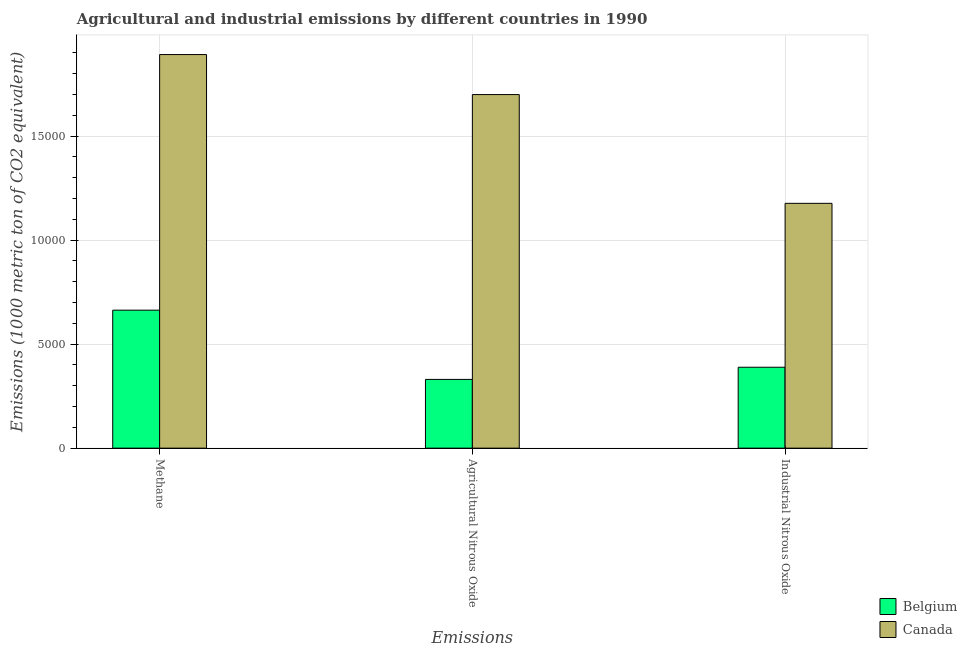How many groups of bars are there?
Make the answer very short. 3. Are the number of bars on each tick of the X-axis equal?
Offer a terse response. Yes. How many bars are there on the 1st tick from the left?
Make the answer very short. 2. What is the label of the 2nd group of bars from the left?
Your response must be concise. Agricultural Nitrous Oxide. What is the amount of agricultural nitrous oxide emissions in Canada?
Make the answer very short. 1.70e+04. Across all countries, what is the maximum amount of industrial nitrous oxide emissions?
Provide a succinct answer. 1.18e+04. Across all countries, what is the minimum amount of agricultural nitrous oxide emissions?
Your answer should be very brief. 3305.4. In which country was the amount of industrial nitrous oxide emissions maximum?
Offer a terse response. Canada. What is the total amount of agricultural nitrous oxide emissions in the graph?
Make the answer very short. 2.03e+04. What is the difference between the amount of industrial nitrous oxide emissions in Canada and that in Belgium?
Give a very brief answer. 7880.4. What is the difference between the amount of methane emissions in Belgium and the amount of industrial nitrous oxide emissions in Canada?
Ensure brevity in your answer.  -5135.7. What is the average amount of agricultural nitrous oxide emissions per country?
Your answer should be compact. 1.02e+04. What is the difference between the amount of methane emissions and amount of agricultural nitrous oxide emissions in Belgium?
Your response must be concise. 3328.9. What is the ratio of the amount of industrial nitrous oxide emissions in Belgium to that in Canada?
Your answer should be compact. 0.33. What is the difference between the highest and the second highest amount of industrial nitrous oxide emissions?
Keep it short and to the point. 7880.4. What is the difference between the highest and the lowest amount of industrial nitrous oxide emissions?
Keep it short and to the point. 7880.4. In how many countries, is the amount of industrial nitrous oxide emissions greater than the average amount of industrial nitrous oxide emissions taken over all countries?
Your answer should be very brief. 1. How many bars are there?
Your answer should be very brief. 6. Are all the bars in the graph horizontal?
Your answer should be compact. No. How many countries are there in the graph?
Give a very brief answer. 2. What is the difference between two consecutive major ticks on the Y-axis?
Keep it short and to the point. 5000. Does the graph contain any zero values?
Offer a very short reply. No. How many legend labels are there?
Offer a terse response. 2. How are the legend labels stacked?
Ensure brevity in your answer.  Vertical. What is the title of the graph?
Offer a very short reply. Agricultural and industrial emissions by different countries in 1990. Does "Middle East & North Africa (all income levels)" appear as one of the legend labels in the graph?
Provide a short and direct response. No. What is the label or title of the X-axis?
Offer a terse response. Emissions. What is the label or title of the Y-axis?
Offer a very short reply. Emissions (1000 metric ton of CO2 equivalent). What is the Emissions (1000 metric ton of CO2 equivalent) in Belgium in Methane?
Keep it short and to the point. 6634.3. What is the Emissions (1000 metric ton of CO2 equivalent) in Canada in Methane?
Give a very brief answer. 1.89e+04. What is the Emissions (1000 metric ton of CO2 equivalent) in Belgium in Agricultural Nitrous Oxide?
Provide a short and direct response. 3305.4. What is the Emissions (1000 metric ton of CO2 equivalent) in Canada in Agricultural Nitrous Oxide?
Give a very brief answer. 1.70e+04. What is the Emissions (1000 metric ton of CO2 equivalent) in Belgium in Industrial Nitrous Oxide?
Offer a very short reply. 3889.6. What is the Emissions (1000 metric ton of CO2 equivalent) in Canada in Industrial Nitrous Oxide?
Ensure brevity in your answer.  1.18e+04. Across all Emissions, what is the maximum Emissions (1000 metric ton of CO2 equivalent) in Belgium?
Your answer should be very brief. 6634.3. Across all Emissions, what is the maximum Emissions (1000 metric ton of CO2 equivalent) of Canada?
Your answer should be compact. 1.89e+04. Across all Emissions, what is the minimum Emissions (1000 metric ton of CO2 equivalent) in Belgium?
Ensure brevity in your answer.  3305.4. Across all Emissions, what is the minimum Emissions (1000 metric ton of CO2 equivalent) in Canada?
Offer a terse response. 1.18e+04. What is the total Emissions (1000 metric ton of CO2 equivalent) in Belgium in the graph?
Your response must be concise. 1.38e+04. What is the total Emissions (1000 metric ton of CO2 equivalent) of Canada in the graph?
Your answer should be compact. 4.77e+04. What is the difference between the Emissions (1000 metric ton of CO2 equivalent) in Belgium in Methane and that in Agricultural Nitrous Oxide?
Make the answer very short. 3328.9. What is the difference between the Emissions (1000 metric ton of CO2 equivalent) of Canada in Methane and that in Agricultural Nitrous Oxide?
Offer a very short reply. 1924.1. What is the difference between the Emissions (1000 metric ton of CO2 equivalent) in Belgium in Methane and that in Industrial Nitrous Oxide?
Make the answer very short. 2744.7. What is the difference between the Emissions (1000 metric ton of CO2 equivalent) of Canada in Methane and that in Industrial Nitrous Oxide?
Provide a short and direct response. 7153.5. What is the difference between the Emissions (1000 metric ton of CO2 equivalent) in Belgium in Agricultural Nitrous Oxide and that in Industrial Nitrous Oxide?
Offer a terse response. -584.2. What is the difference between the Emissions (1000 metric ton of CO2 equivalent) of Canada in Agricultural Nitrous Oxide and that in Industrial Nitrous Oxide?
Your response must be concise. 5229.4. What is the difference between the Emissions (1000 metric ton of CO2 equivalent) of Belgium in Methane and the Emissions (1000 metric ton of CO2 equivalent) of Canada in Agricultural Nitrous Oxide?
Make the answer very short. -1.04e+04. What is the difference between the Emissions (1000 metric ton of CO2 equivalent) of Belgium in Methane and the Emissions (1000 metric ton of CO2 equivalent) of Canada in Industrial Nitrous Oxide?
Give a very brief answer. -5135.7. What is the difference between the Emissions (1000 metric ton of CO2 equivalent) in Belgium in Agricultural Nitrous Oxide and the Emissions (1000 metric ton of CO2 equivalent) in Canada in Industrial Nitrous Oxide?
Offer a very short reply. -8464.6. What is the average Emissions (1000 metric ton of CO2 equivalent) of Belgium per Emissions?
Your answer should be compact. 4609.77. What is the average Emissions (1000 metric ton of CO2 equivalent) of Canada per Emissions?
Keep it short and to the point. 1.59e+04. What is the difference between the Emissions (1000 metric ton of CO2 equivalent) of Belgium and Emissions (1000 metric ton of CO2 equivalent) of Canada in Methane?
Give a very brief answer. -1.23e+04. What is the difference between the Emissions (1000 metric ton of CO2 equivalent) in Belgium and Emissions (1000 metric ton of CO2 equivalent) in Canada in Agricultural Nitrous Oxide?
Offer a very short reply. -1.37e+04. What is the difference between the Emissions (1000 metric ton of CO2 equivalent) of Belgium and Emissions (1000 metric ton of CO2 equivalent) of Canada in Industrial Nitrous Oxide?
Your response must be concise. -7880.4. What is the ratio of the Emissions (1000 metric ton of CO2 equivalent) of Belgium in Methane to that in Agricultural Nitrous Oxide?
Provide a succinct answer. 2.01. What is the ratio of the Emissions (1000 metric ton of CO2 equivalent) of Canada in Methane to that in Agricultural Nitrous Oxide?
Provide a succinct answer. 1.11. What is the ratio of the Emissions (1000 metric ton of CO2 equivalent) in Belgium in Methane to that in Industrial Nitrous Oxide?
Make the answer very short. 1.71. What is the ratio of the Emissions (1000 metric ton of CO2 equivalent) in Canada in Methane to that in Industrial Nitrous Oxide?
Your answer should be very brief. 1.61. What is the ratio of the Emissions (1000 metric ton of CO2 equivalent) of Belgium in Agricultural Nitrous Oxide to that in Industrial Nitrous Oxide?
Your answer should be very brief. 0.85. What is the ratio of the Emissions (1000 metric ton of CO2 equivalent) in Canada in Agricultural Nitrous Oxide to that in Industrial Nitrous Oxide?
Offer a very short reply. 1.44. What is the difference between the highest and the second highest Emissions (1000 metric ton of CO2 equivalent) of Belgium?
Provide a succinct answer. 2744.7. What is the difference between the highest and the second highest Emissions (1000 metric ton of CO2 equivalent) in Canada?
Make the answer very short. 1924.1. What is the difference between the highest and the lowest Emissions (1000 metric ton of CO2 equivalent) of Belgium?
Provide a succinct answer. 3328.9. What is the difference between the highest and the lowest Emissions (1000 metric ton of CO2 equivalent) of Canada?
Give a very brief answer. 7153.5. 